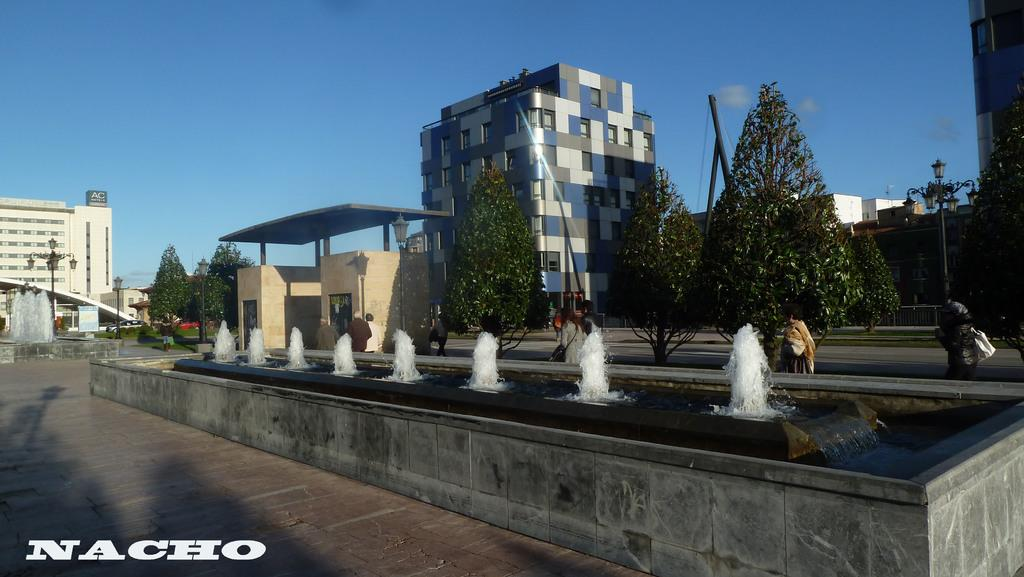What natural feature is the main subject of the image? There is a waterfall in the image. What can be seen in the background of the image? There is a group of people walking in the background. What type of vegetation is present in the image? There are trees with green color in the image. What type of structures can be seen in the image? There are buildings with cream, blue, and white colors in the image. What is the color of the sky in the image? The sky is blue in the image. What type of chair is being used to catch the silk in the image? There is no chair or silk present in the image. What type of juice is being served to the people in the image? There is no juice or indication of a gathering in the image. 